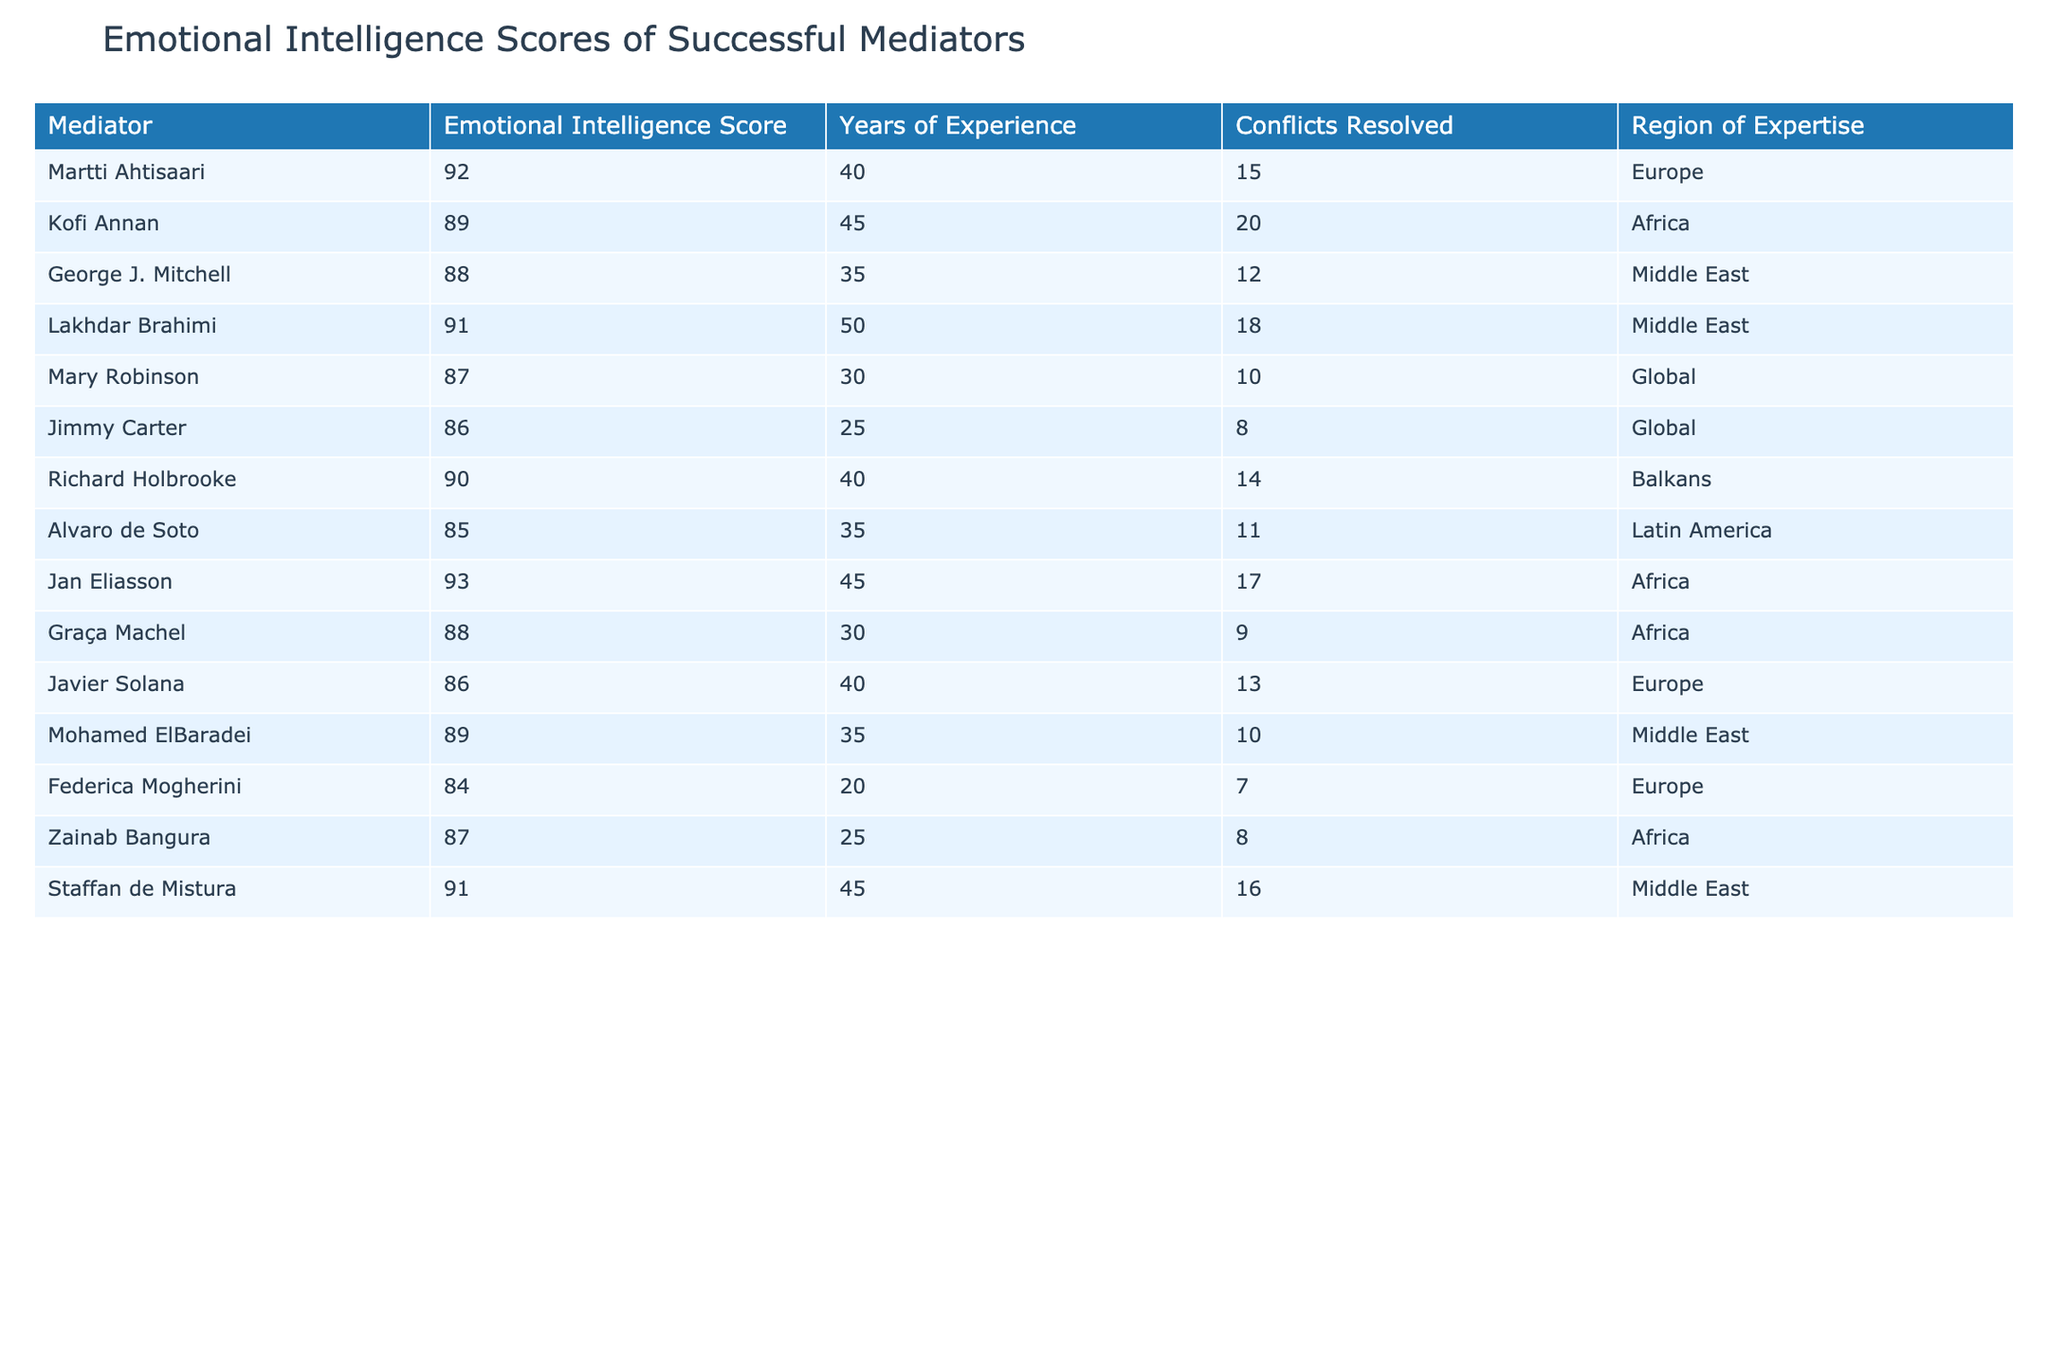What is the highest emotional intelligence score among the mediators? The highest emotional intelligence score in the table is 93, which belongs to Jan Eliasson.
Answer: 93 Who has the least years of experience among the listed mediators? Jimmy Carter has the least years of experience, with only 25 years.
Answer: 25 How many conflicts did Kofi Annan resolve? Kofi Annan resolved 20 conflicts, as stated in the corresponding cell of the table.
Answer: 20 Is Lakhdar Brahimi's emotional intelligence score higher than Richard Holbrooke's? Lakhdar Brahimi has a score of 91, while Richard Holbrooke has a score of 90; thus, yes, it is higher.
Answer: Yes What is the average emotional intelligence score of the mediators in the Middle East region? The scores for mediators in the Middle East are 88, 91, 89, and 91. Summing them gives 88 + 91 + 89 + 91 = 359. There are 4 scores, so the average is 359/4 = 89.75.
Answer: 89.75 Which mediator resolved the most conflicts and what is their score? Kofi Annan resolved the most conflicts with a total of 20, and his emotional intelligence score is 89.
Answer: 20 conflicts, score 89 How many mediators have an emotional intelligence score of 86 or lower? There are three mediators with scores of 86 or lower: Jimmy Carter (86), Alvaro de Soto (85), and Federica Mogherini (84).
Answer: 3 What is the difference in emotional intelligence scores between the highest and lowest scoring mediators? The highest score is 93 (Jan Eliasson) and the lowest score is 84 (Federica Mogherini). The difference is calculated as 93 - 84 = 9.
Answer: 9 Are there more mediators from Europe or Africa? Europe has 4 mediators (Martti Ahtisaari, Javier Solana, Federica Mogherini) and Africa has 5 (Kofi Annan, Jan Eliasson, Graça Machel, Zainab Bangura). Hence, there are more from Africa.
Answer: Africa What is the total number of conflicts resolved by mediators in the African region? The conflicts resolved by African mediators are 20 (Kofi Annan) + 17 (Jan Eliasson) + 9 (Graça Machel) + 8 (Zainab Bangura) = 54.
Answer: 54 